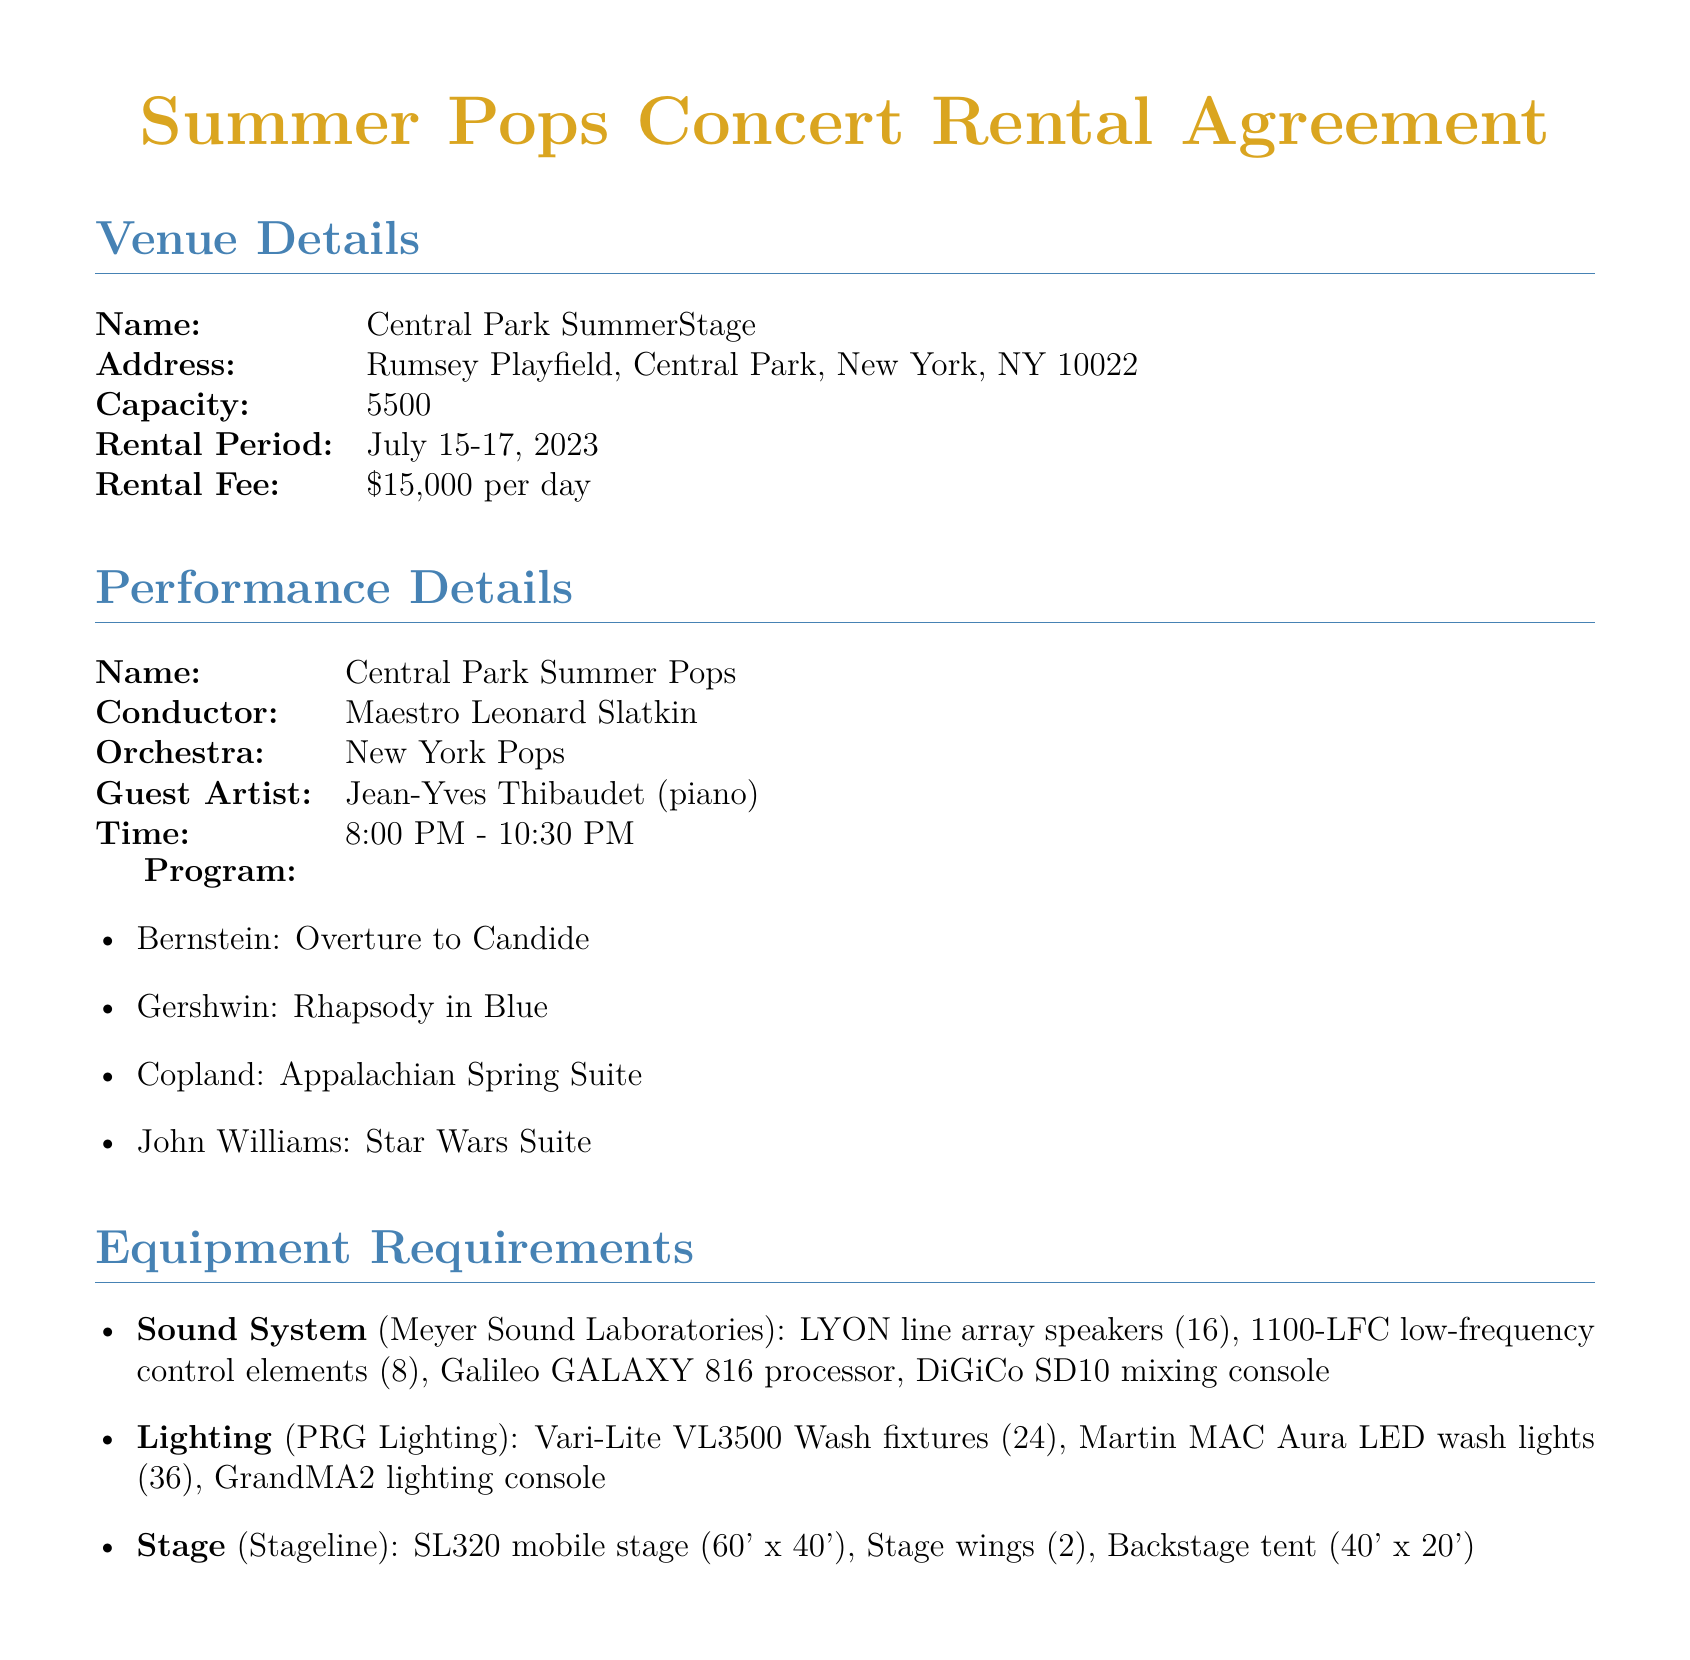What is the rental fee per day? The document states that the rental fee is $15,000 per day.
Answer: $15,000 per day How many security personnel are required? The document lists the quantity of security personnel required as 20.
Answer: 20 Who is the guest artist for the concert? The document specifies that the guest artist is Jean-Yves Thibaudet (piano).
Answer: Jean-Yves Thibaudet (piano) What is the total capacity of the venue? The capacity listed in the document for Central Park SummerStage is 5500.
Answer: 5500 What is the cancellation refund percentage? The document indicates a refund percentage of 50% of the rental fee for cancellations.
Answer: 50% What is the rental period for the venue? The document specifies the rental period as July 15-17, 2023.
Answer: July 15-17, 2023 How many stagehands are needed? According to the document, the quantity of stagehands required is 8.
Answer: 8 What is the insurance requirement for general liability? The document states that the general liability requirement is $2 million per occurrence.
Answer: $2 million per occurrence What is the deadline for cancellation? The deadline for cancellation as mentioned in the document is 30 days prior to the event.
Answer: 30 days prior to event 